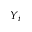Convert formula to latex. <formula><loc_0><loc_0><loc_500><loc_500>Y _ { i }</formula> 